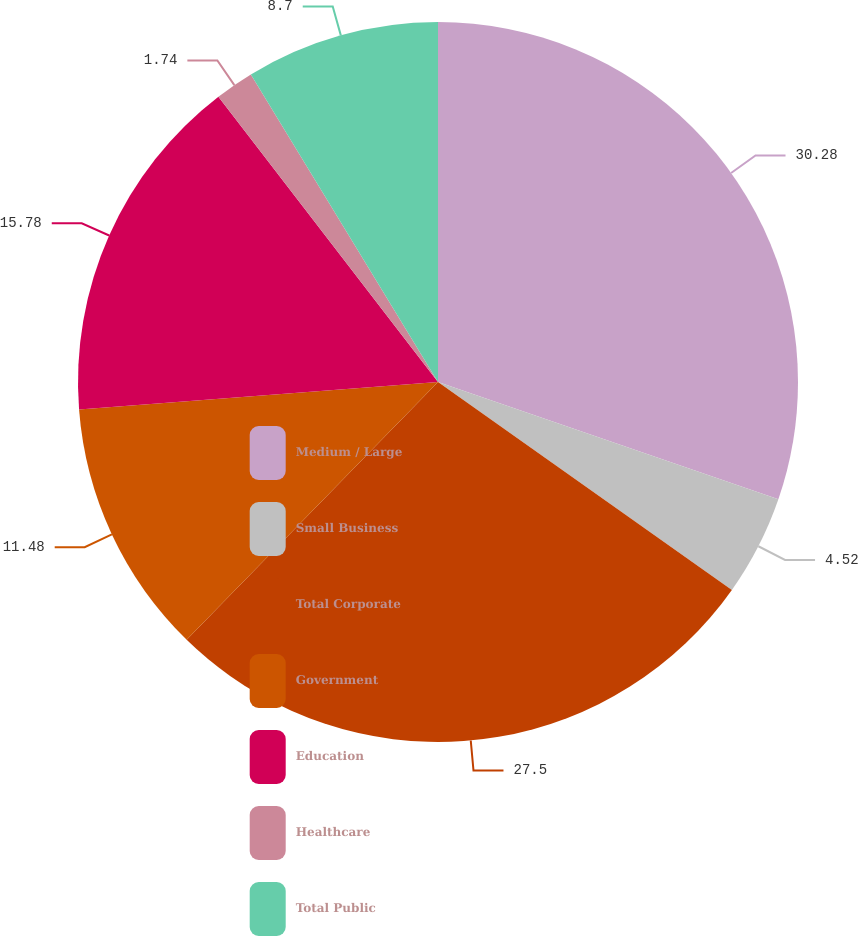Convert chart. <chart><loc_0><loc_0><loc_500><loc_500><pie_chart><fcel>Medium / Large<fcel>Small Business<fcel>Total Corporate<fcel>Government<fcel>Education<fcel>Healthcare<fcel>Total Public<nl><fcel>30.28%<fcel>4.52%<fcel>27.5%<fcel>11.48%<fcel>15.78%<fcel>1.74%<fcel>8.7%<nl></chart> 